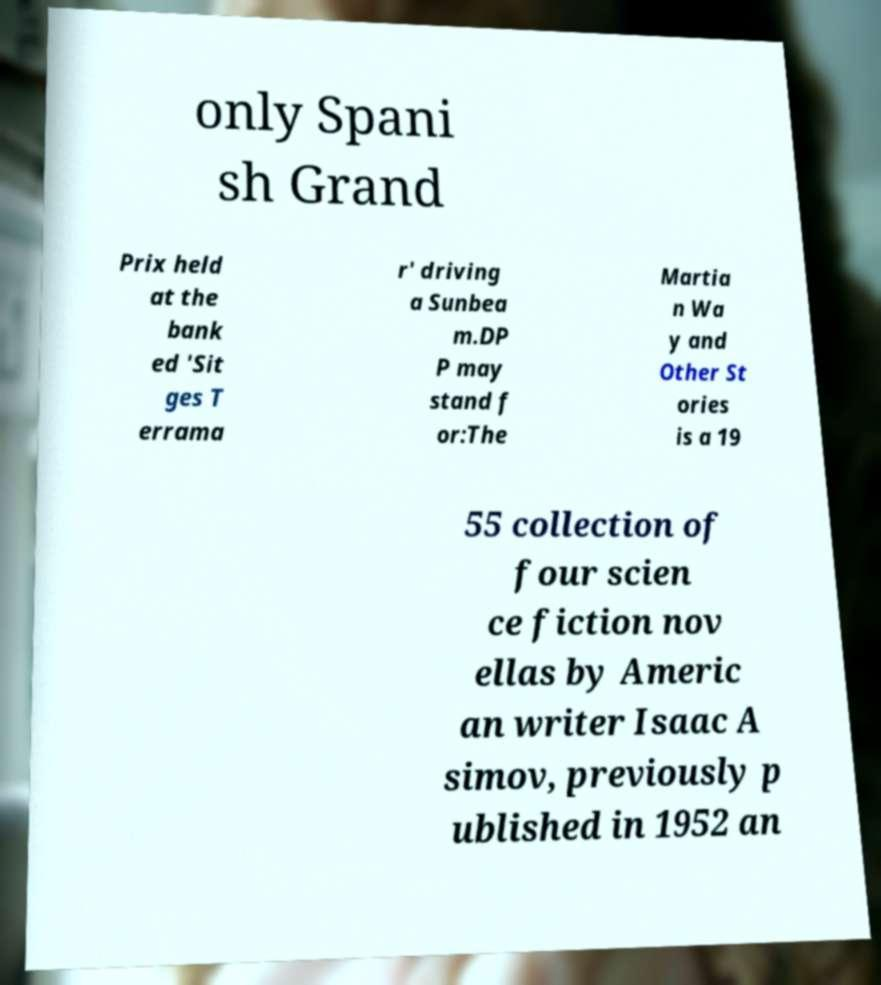Can you read and provide the text displayed in the image?This photo seems to have some interesting text. Can you extract and type it out for me? only Spani sh Grand Prix held at the bank ed 'Sit ges T errama r' driving a Sunbea m.DP P may stand f or:The Martia n Wa y and Other St ories is a 19 55 collection of four scien ce fiction nov ellas by Americ an writer Isaac A simov, previously p ublished in 1952 an 